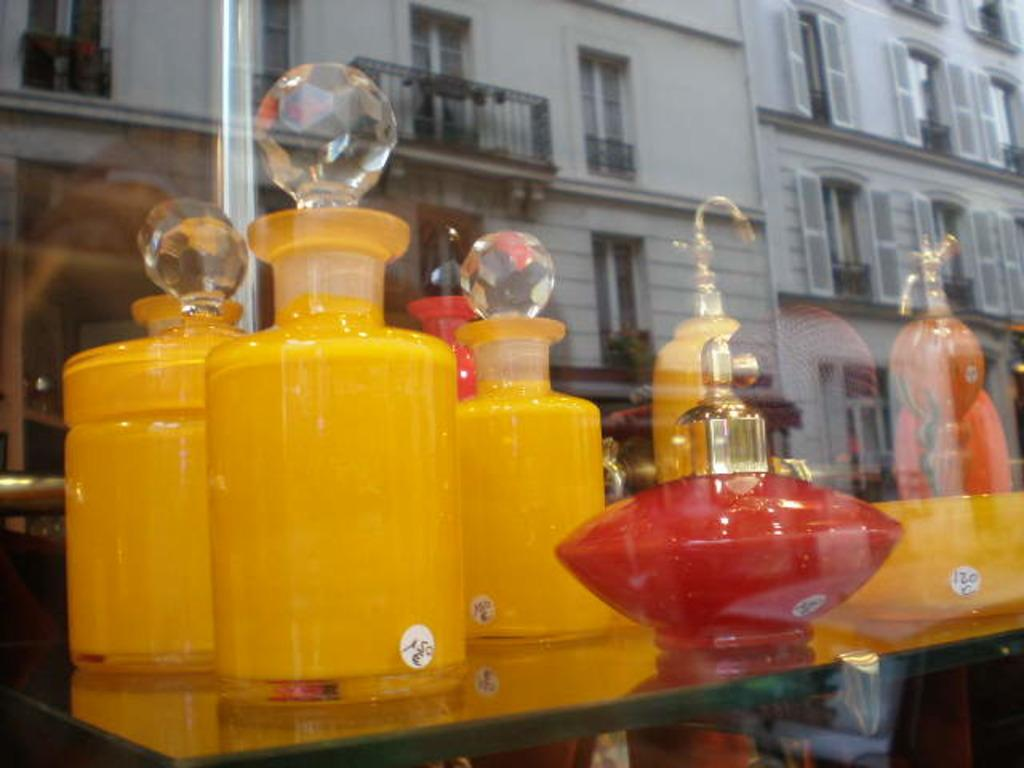What type of containers are visible in the image? There are glass bottles in the image. Where are the glass bottles located? The glass bottles are on a shelf. What can be seen in the background of the image? There are buildings visible in the background of the image. What type of waves can be heard in the image? There are no waves present in the image, as it is a still image and does not contain any sound. 